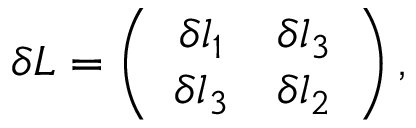<formula> <loc_0><loc_0><loc_500><loc_500>\delta L = \left ( \begin{array} { c r c } { { \delta l _ { 1 } } } & { { \delta l _ { 3 } } } \\ { { \delta l _ { 3 } } } & { { \delta l _ { 2 } } } \end{array} \right ) ,</formula> 